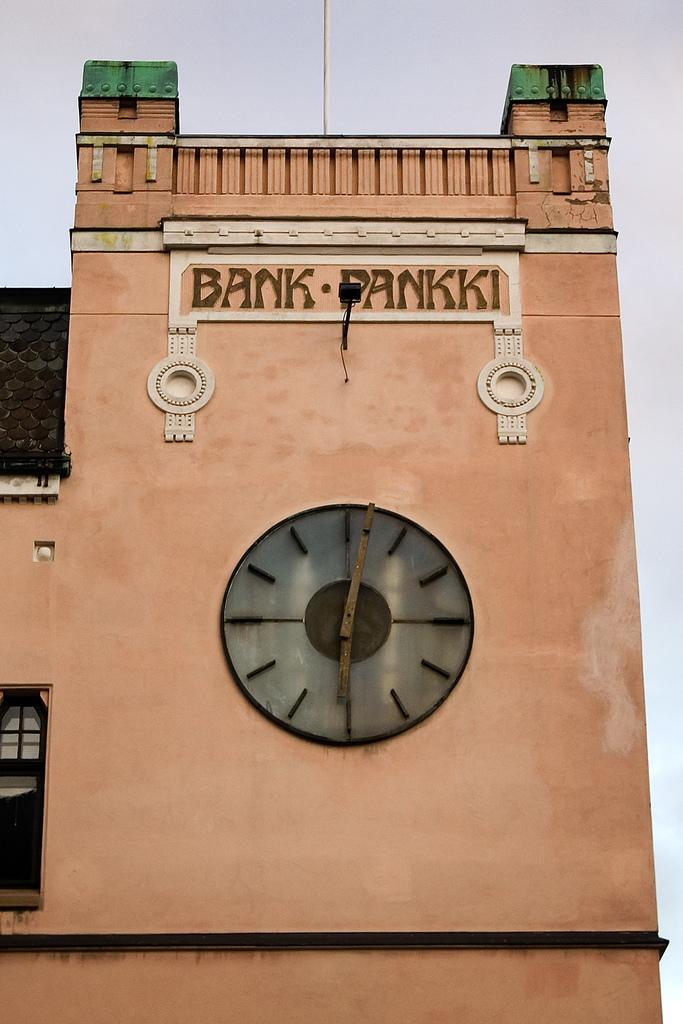<image>
Provide a brief description of the given image. An old orange brown building with a clock in the middle and a sign that reads Bank Pankki 